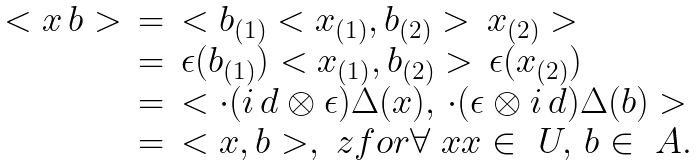Convert formula to latex. <formula><loc_0><loc_0><loc_500><loc_500>\begin{array} { r c l } < x \, b > & = & < b _ { ( 1 ) } < x _ { ( 1 ) } , b _ { ( 2 ) } > \, x _ { ( 2 ) } > \\ & = & \epsilon ( b _ { ( 1 ) } ) < x _ { ( 1 ) } , b _ { ( 2 ) } > \, \epsilon ( x _ { ( 2 ) } ) \\ & = & < \cdot ( i \, d \otimes \epsilon ) \Delta ( x ) , \, \cdot ( \epsilon \otimes i \, d ) \Delta ( b ) > \\ & = & < x , b > , \ z f o r \forall \ x x \in \ U , \, b \in \ A . \end{array}</formula> 